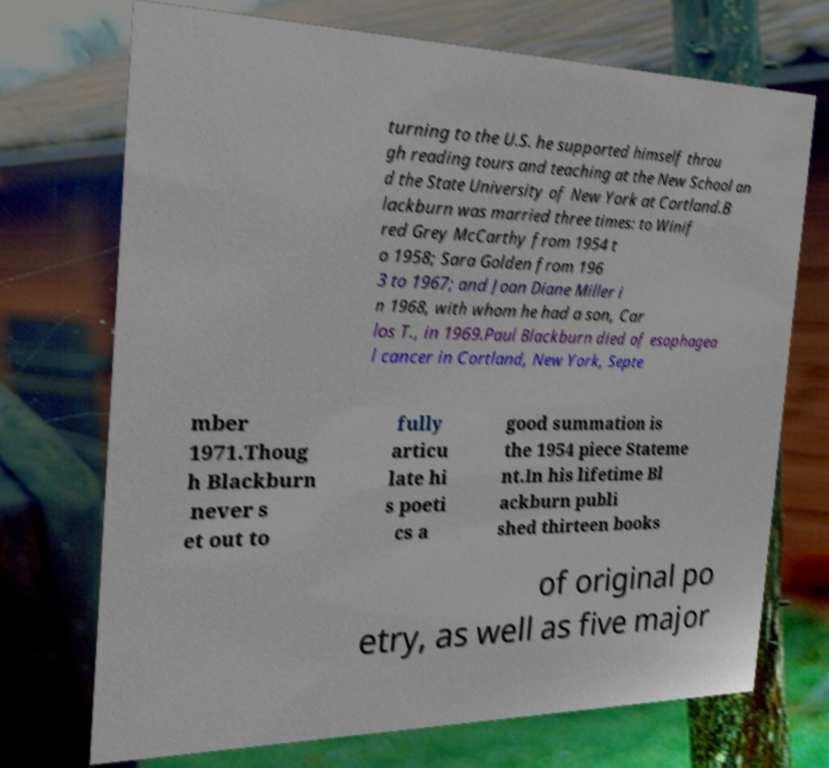Please identify and transcribe the text found in this image. turning to the U.S. he supported himself throu gh reading tours and teaching at the New School an d the State University of New York at Cortland.B lackburn was married three times: to Winif red Grey McCarthy from 1954 t o 1958; Sara Golden from 196 3 to 1967; and Joan Diane Miller i n 1968, with whom he had a son, Car los T., in 1969.Paul Blackburn died of esophagea l cancer in Cortland, New York, Septe mber 1971.Thoug h Blackburn never s et out to fully articu late hi s poeti cs a good summation is the 1954 piece Stateme nt.In his lifetime Bl ackburn publi shed thirteen books of original po etry, as well as five major 